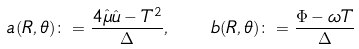Convert formula to latex. <formula><loc_0><loc_0><loc_500><loc_500>a ( R , \theta ) \colon = \frac { 4 \hat { \mu } \hat { u } - T ^ { 2 } } { \Delta } , \quad b ( R , \theta ) \colon = \frac { \Phi - \omega T } { \Delta }</formula> 